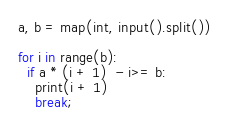Convert code to text. <code><loc_0><loc_0><loc_500><loc_500><_Python_>a, b = map(int, input().split())

for i in range(b):
  if a * (i + 1)  - i>= b:
    print(i + 1)
    break;</code> 